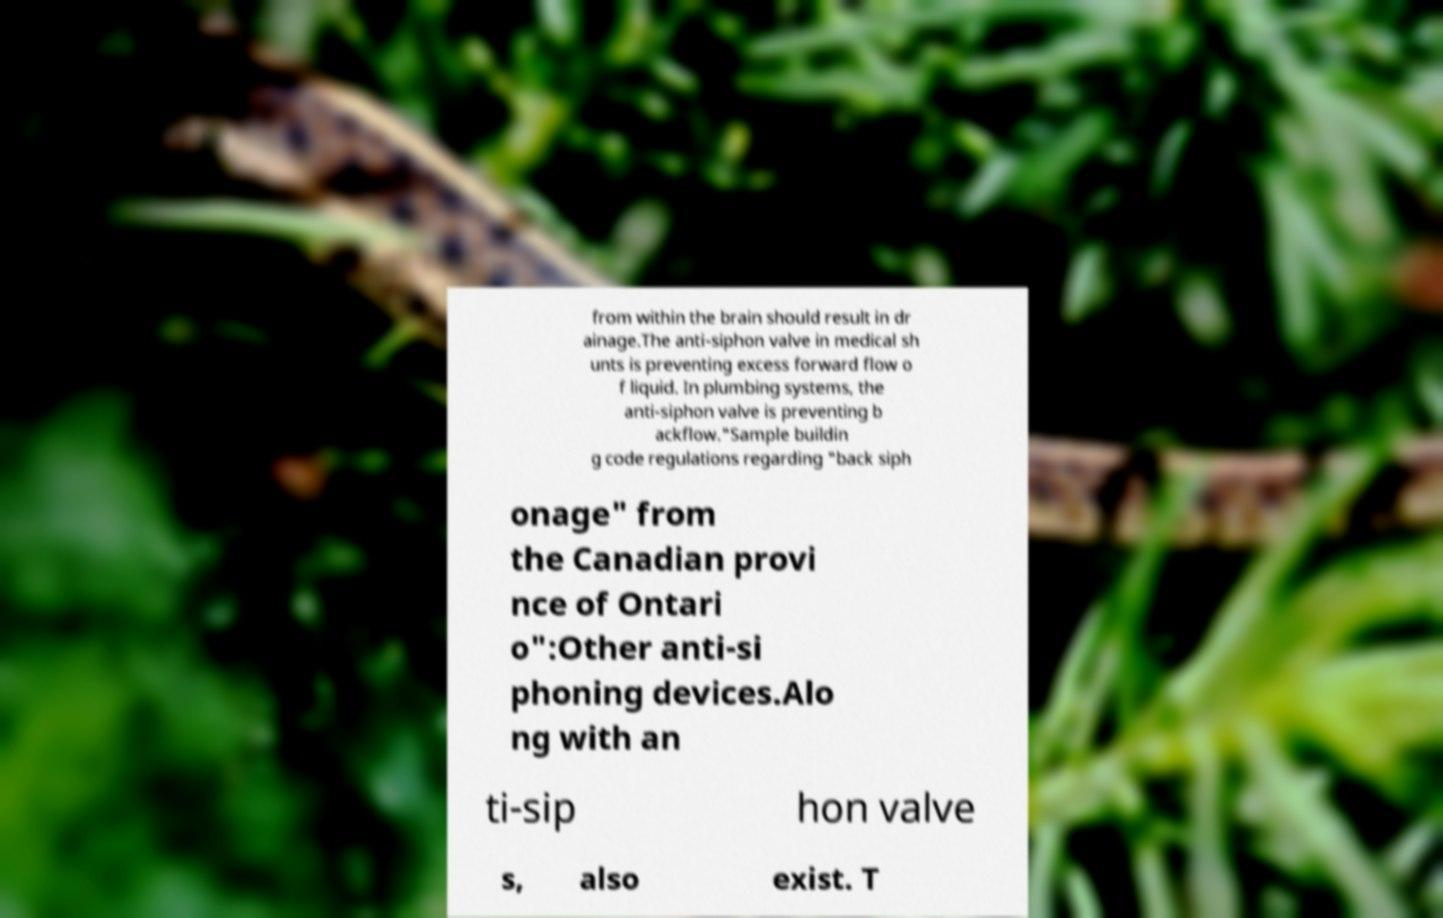There's text embedded in this image that I need extracted. Can you transcribe it verbatim? from within the brain should result in dr ainage.The anti-siphon valve in medical sh unts is preventing excess forward flow o f liquid. In plumbing systems, the anti-siphon valve is preventing b ackflow."Sample buildin g code regulations regarding "back siph onage" from the Canadian provi nce of Ontari o":Other anti-si phoning devices.Alo ng with an ti-sip hon valve s, also exist. T 